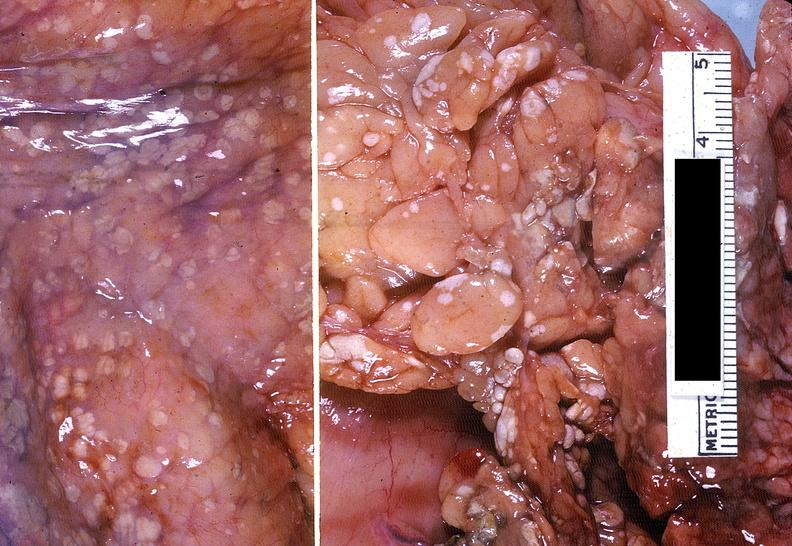how does this image show acute pancreatitis?
Answer the question using a single word or phrase. With fat necrosis 